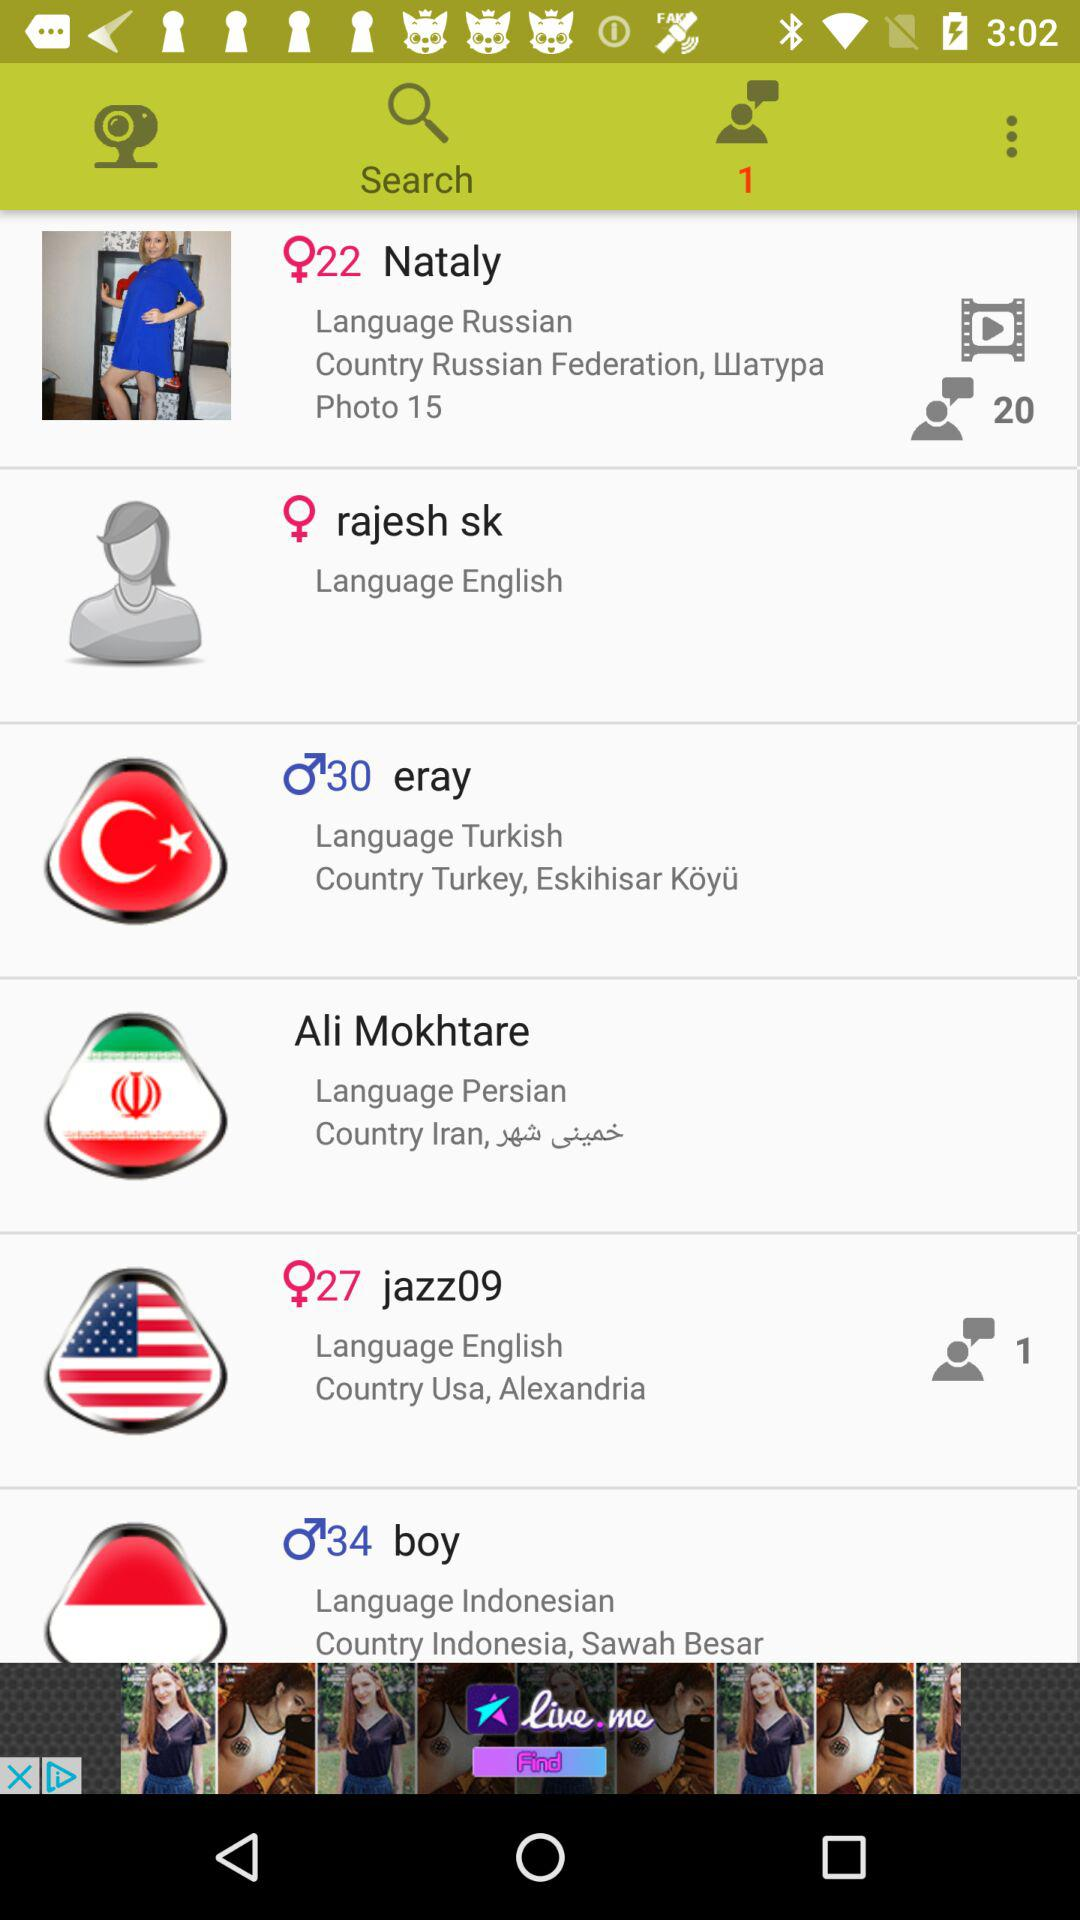How many items have a language other than English?
Answer the question using a single word or phrase. 4 